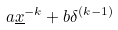Convert formula to latex. <formula><loc_0><loc_0><loc_500><loc_500>a \underline { x } ^ { - k } + b \delta ^ { ( k - 1 ) }</formula> 